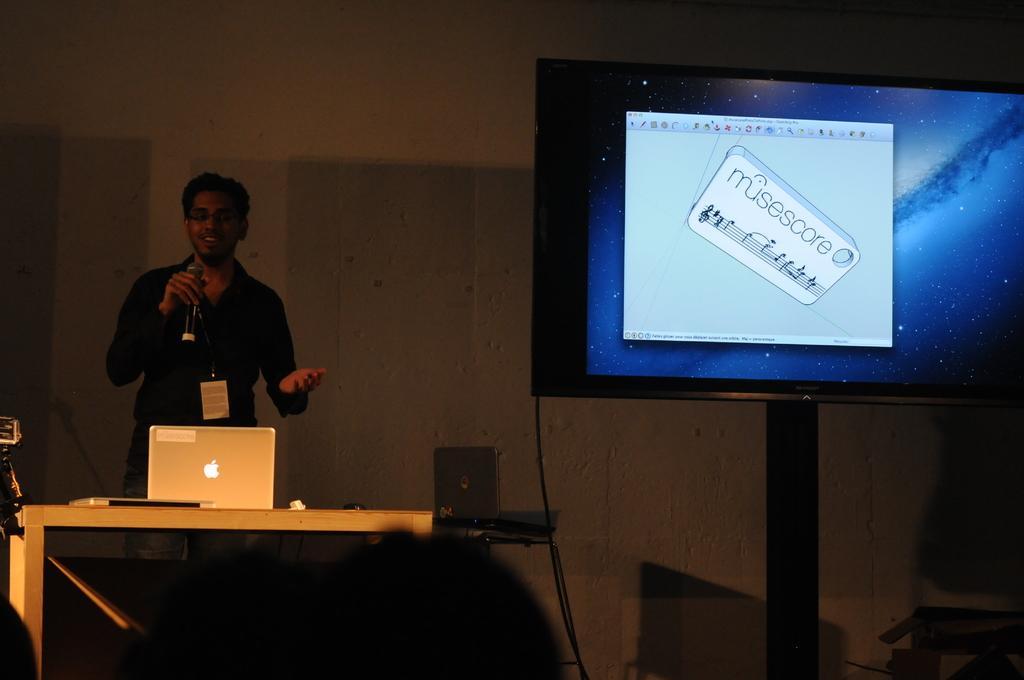Could you give a brief overview of what you see in this image? In this picture there is a man standing and holding a mic in his hand. There is a laptop on the table. There is also another laptop on the table. There is a screen and a box. 